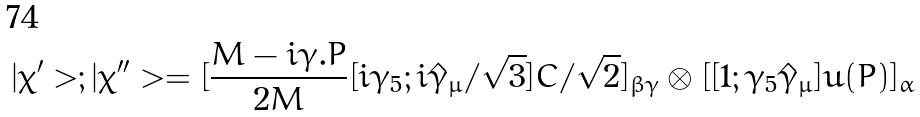<formula> <loc_0><loc_0><loc_500><loc_500>| \chi ^ { \prime } > ; | \chi ^ { \prime \prime } > = [ \frac { M - i \gamma . P } { 2 M } [ i \gamma _ { 5 } ; i { \hat { \gamma } } _ { \mu } / \sqrt { 3 } ] C / \sqrt { 2 } ] _ { \beta \gamma } \otimes [ [ 1 ; \gamma _ { 5 } { \hat { \gamma } } _ { \mu } ] u ( P ) ] _ { \alpha }</formula> 